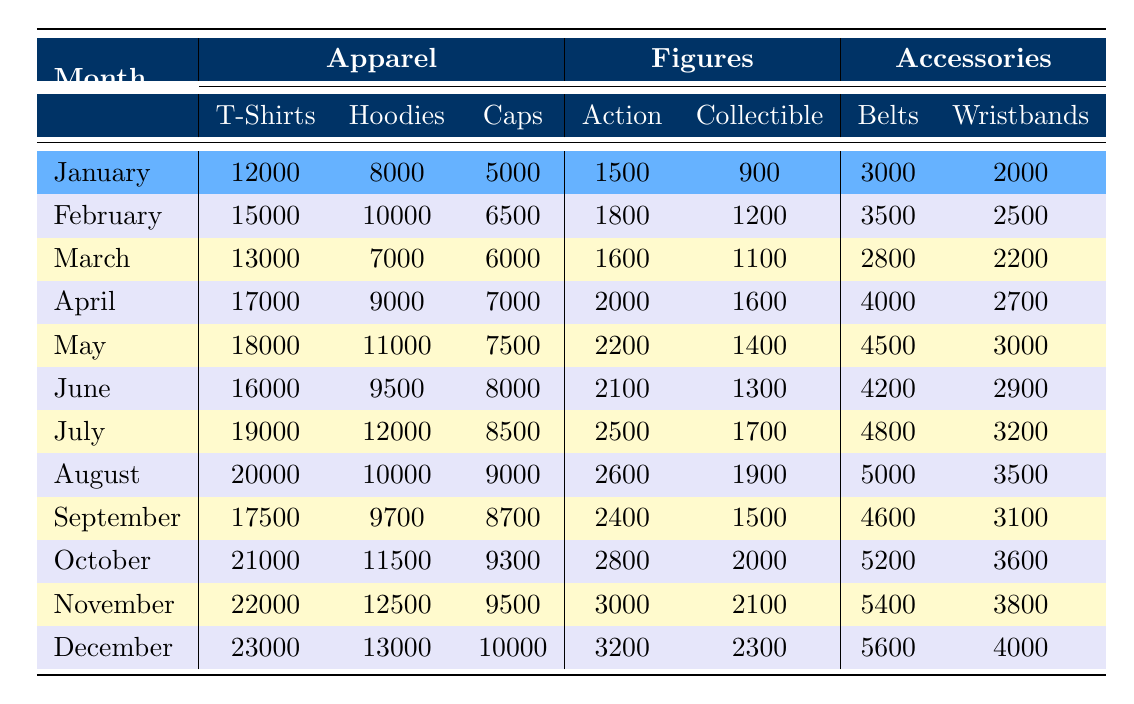What's the total number of T-shirts sold in January? Referring to the table, under January in the Apparel section, the number of T-shirts sold is 12,000.
Answer: 12000 Which month had the highest sales of Action Figures? Looking through the table, by comparing the values for Action Figures, the highest sales occurred in December, with 3,200 units sold.
Answer: December What was the average number of Hoodies sold from January to March? To find the average, sum up the Hoodies sold in those months: 8,000 (Jan) + 10,000 (Feb) + 7,000 (Mar) = 25,000. Then, divide by the number of months (3): 25,000 / 3 = 8,333.33, so the average rounds to 8,333.
Answer: 8333 Did more Caps sell in July than in June? Checking the Caps sales, July shows 8,500 while June shows 8,000, so more Caps were sold in July.
Answer: Yes How many total Accessories were sold in April? For April, add the totals of Belts and Wristbands: 4,000 (Belts) + 2,700 (Wristbands) = 6,700 total Accessories sold.
Answer: 6700 What is the difference in T-shirt sales between October and January? The sales in October are 21,000 and in January are 12,000. The difference is 21,000 - 12,000 = 9,000.
Answer: 9000 What was the overall trend for Figures sales from January to December? Analyzing the data, Figures sales show a consistent increase over the months, starting at 2,400 for September and reaching a peak of 3,200 in December.
Answer: Increasing Which two months had the same number of Collectible Figurines sold? Checking the values for Collectible Figurines, the months of June (1,300) and July (1,700) do not match. However, November (2,100) and December (2,300) also do not match too. Therefore, by reviewing the table, there are no months with the same sales figure.
Answer: None How many more Wristbands were sold in November compared to January? In November, Wristbands sold totaled 3,800, while in January they were 2,000. The difference is 3,800 - 2,000 = 1,800 more sold in November.
Answer: 1800 What was the highest number of Caps sold in any month, and which month was it? The highest number of Caps sold was in October with 9,300.
Answer: October with 9300 